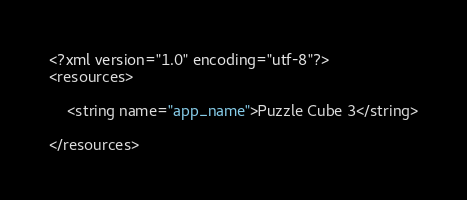<code> <loc_0><loc_0><loc_500><loc_500><_XML_><?xml version="1.0" encoding="utf-8"?>
<resources>

    <string name="app_name">Puzzle Cube 3</string>

</resources></code> 